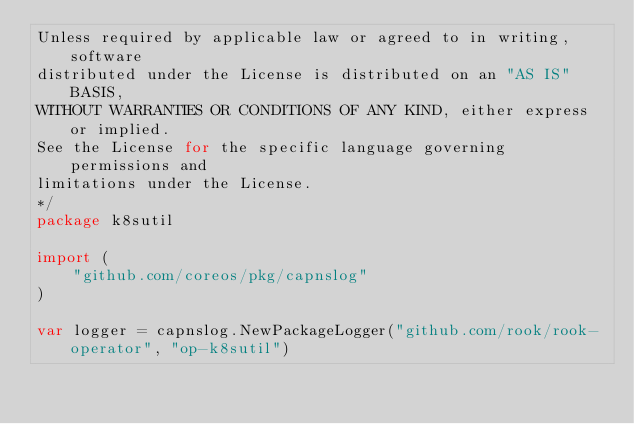Convert code to text. <code><loc_0><loc_0><loc_500><loc_500><_Go_>Unless required by applicable law or agreed to in writing, software
distributed under the License is distributed on an "AS IS" BASIS,
WITHOUT WARRANTIES OR CONDITIONS OF ANY KIND, either express or implied.
See the License for the specific language governing permissions and
limitations under the License.
*/
package k8sutil

import (
	"github.com/coreos/pkg/capnslog"
)

var logger = capnslog.NewPackageLogger("github.com/rook/rook-operator", "op-k8sutil")
</code> 